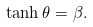Convert formula to latex. <formula><loc_0><loc_0><loc_500><loc_500>\tanh \theta = \beta .</formula> 